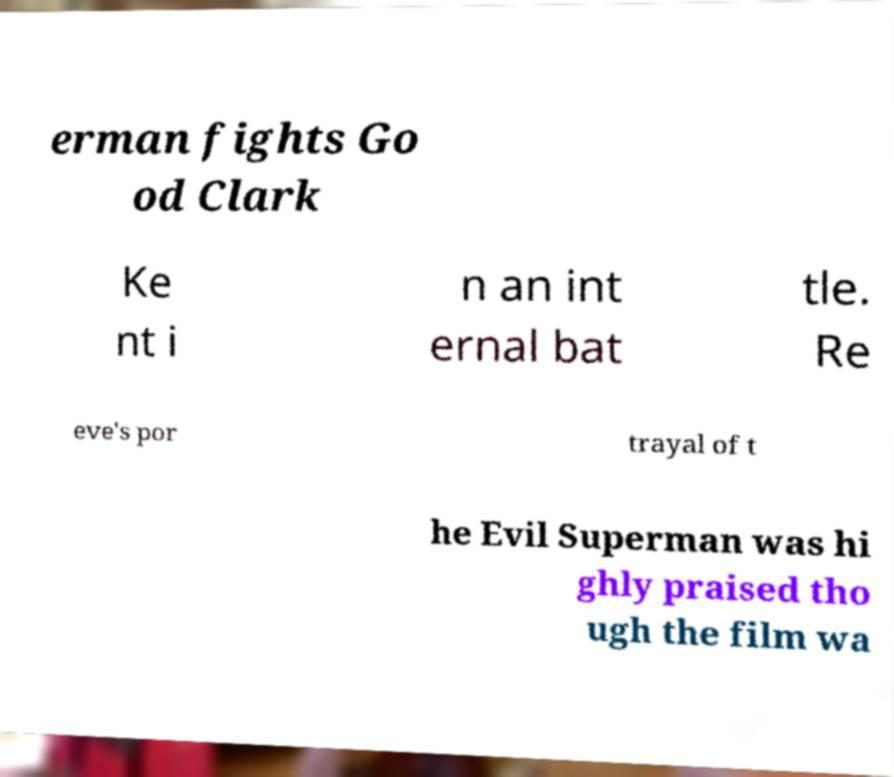For documentation purposes, I need the text within this image transcribed. Could you provide that? erman fights Go od Clark Ke nt i n an int ernal bat tle. Re eve's por trayal of t he Evil Superman was hi ghly praised tho ugh the film wa 